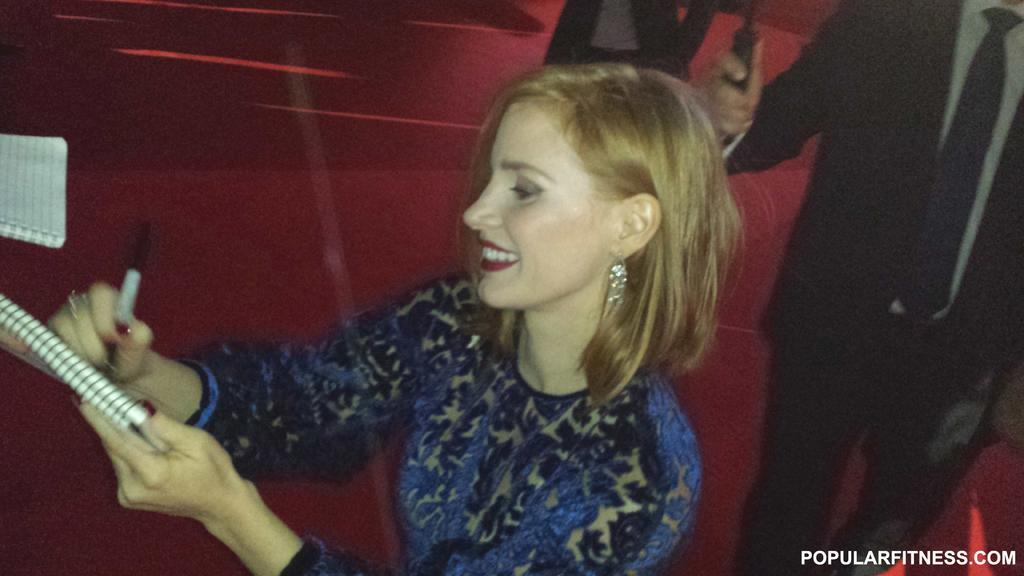Who is the main subject in the image? There is a woman in the image. What is the woman doing in the image? The woman is standing and writing on a book. What items is the woman holding in the image? The woman is holding a book and a pen. Can you describe the people in the background of the image? There are two people in the background, and one of them is holding an object in their hand. What type of pet can be seen in the image? There is no pet visible in the image. How many objects are being held by the person in the background? The provided facts do not specify the number of objects being held by the person in the background. 